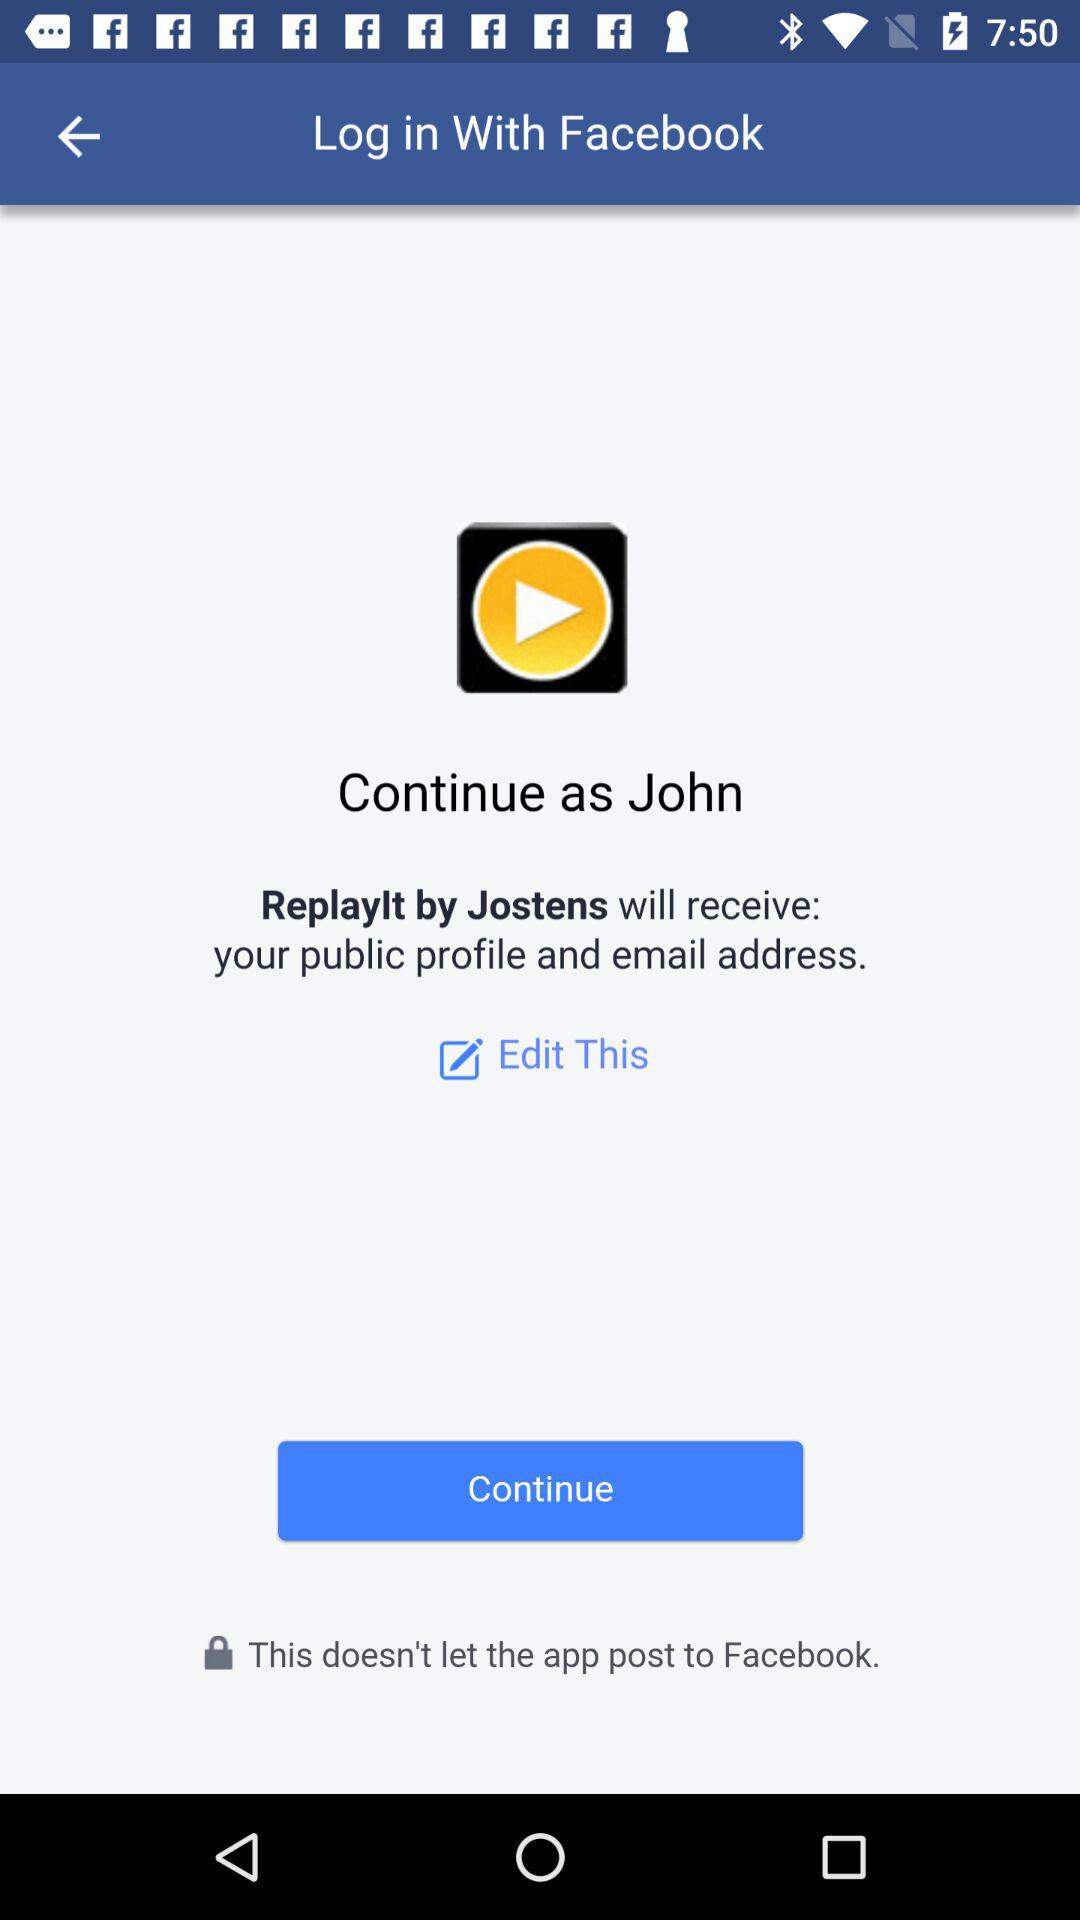Through what application can we log in? We can login through "Facebook". 